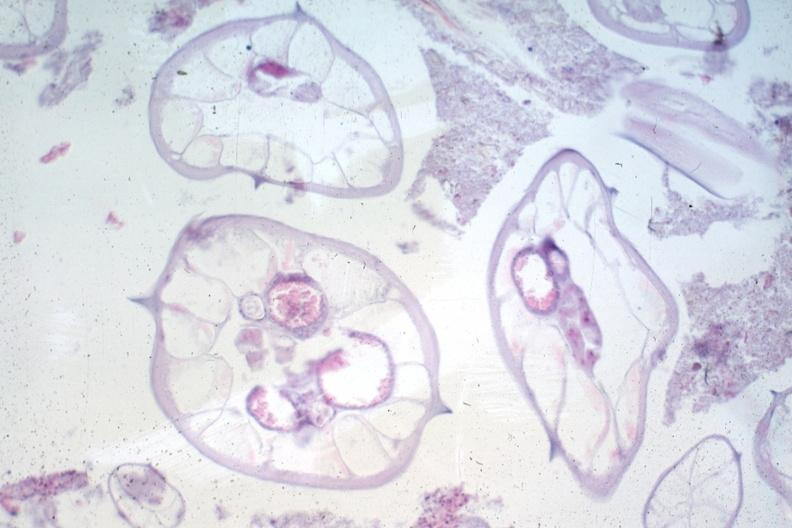what is present?
Answer the question using a single word or phrase. Gastrointestinal 